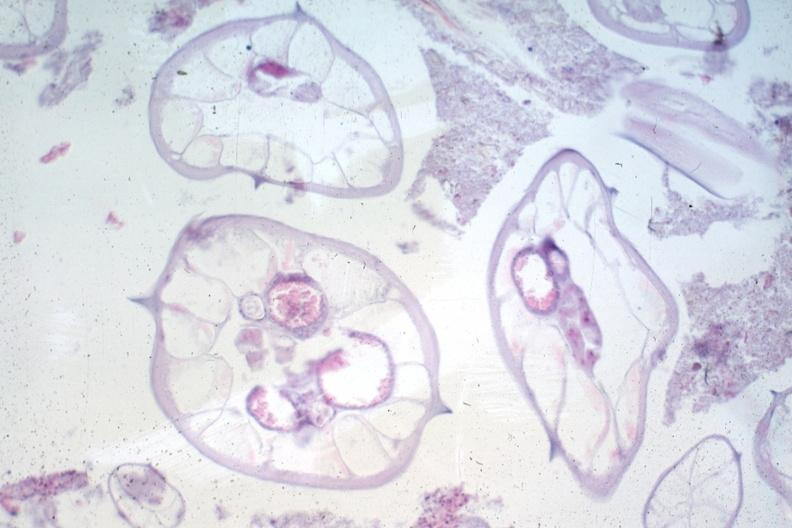what is present?
Answer the question using a single word or phrase. Gastrointestinal 